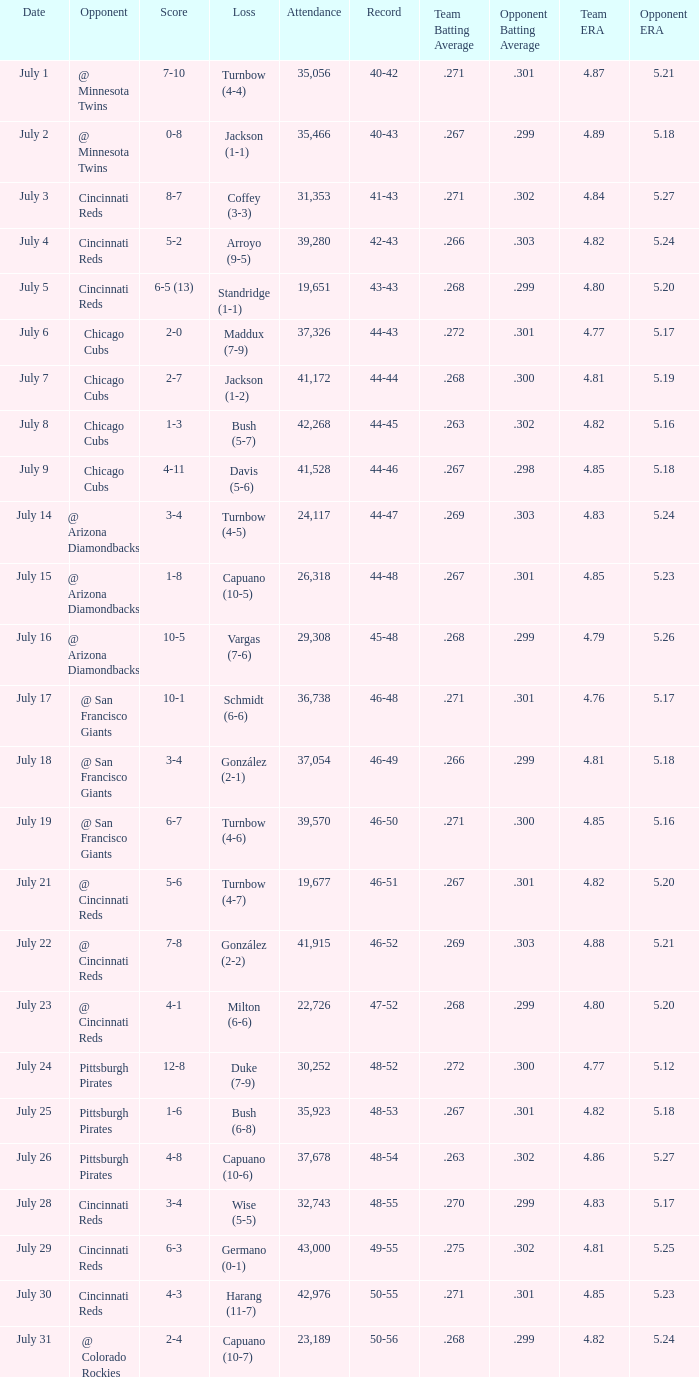What was the loss of the Brewers game when the record was 46-48? Schmidt (6-6). 